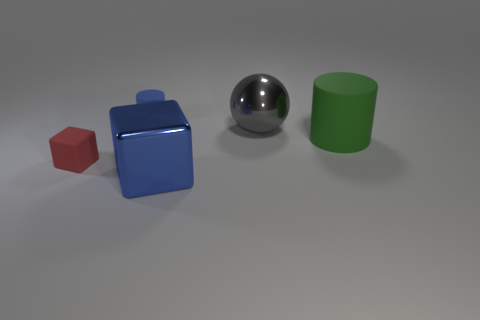There is a cylinder that is behind the matte object that is right of the big thing that is in front of the tiny red thing; what is its material?
Your response must be concise. Rubber. Is there anything else that has the same shape as the large gray object?
Make the answer very short. No. What is the color of the other object that is the same shape as the tiny blue matte object?
Offer a terse response. Green. Is the color of the matte cylinder that is left of the green matte cylinder the same as the cube that is to the right of the small rubber cylinder?
Your response must be concise. Yes. Are there more shiny things that are in front of the green matte cylinder than purple shiny cubes?
Offer a very short reply. Yes. How many other things are the same size as the blue cylinder?
Offer a terse response. 1. What number of things are both left of the green thing and on the right side of the tiny matte cylinder?
Ensure brevity in your answer.  2. Does the tiny thing behind the red rubber object have the same material as the gray sphere?
Make the answer very short. No. There is a big metallic thing behind the blue object that is on the right side of the blue object behind the green cylinder; what shape is it?
Keep it short and to the point. Sphere. Is the number of cubes on the right side of the green cylinder the same as the number of large blue things that are on the left side of the blue rubber cylinder?
Provide a short and direct response. Yes. 